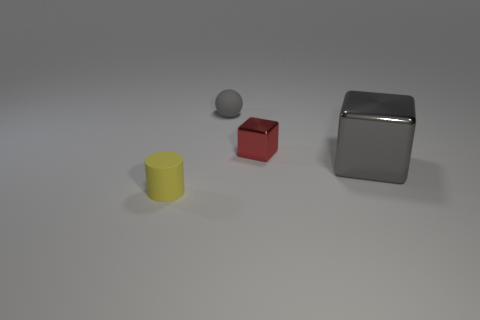What number of large blocks are behind the tiny matte object left of the small gray rubber object?
Give a very brief answer. 1. How many big green metallic cylinders are there?
Your answer should be very brief. 0. Is the material of the cylinder the same as the gray thing behind the gray block?
Your response must be concise. Yes. Do the tiny matte object behind the gray cube and the big object have the same color?
Provide a succinct answer. Yes. The tiny object that is both behind the large gray shiny block and in front of the tiny gray matte sphere is made of what material?
Provide a short and direct response. Metal. What size is the gray sphere?
Keep it short and to the point. Small. Is the color of the tiny cube the same as the rubber object behind the tiny red shiny cube?
Give a very brief answer. No. How many other things are the same color as the tiny sphere?
Ensure brevity in your answer.  1. Is the size of the rubber object behind the rubber cylinder the same as the shiny cube in front of the small metal block?
Your answer should be very brief. No. There is a matte object behind the tiny red thing; what color is it?
Ensure brevity in your answer.  Gray. 